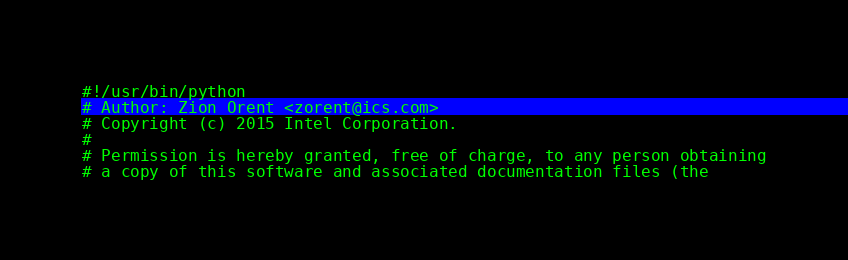Convert code to text. <code><loc_0><loc_0><loc_500><loc_500><_Python_>#!/usr/bin/python
# Author: Zion Orent <zorent@ics.com>
# Copyright (c) 2015 Intel Corporation.
#
# Permission is hereby granted, free of charge, to any person obtaining
# a copy of this software and associated documentation files (the</code> 